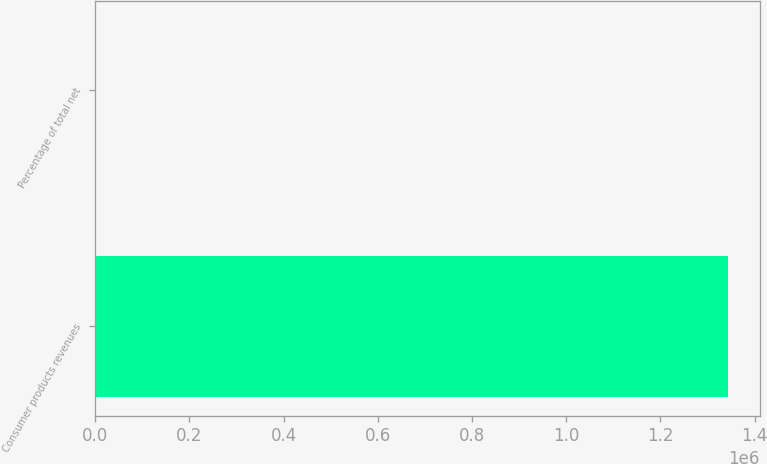<chart> <loc_0><loc_0><loc_500><loc_500><bar_chart><fcel>Consumer products revenues<fcel>Percentage of total net<nl><fcel>1.34306e+06<fcel>52<nl></chart> 